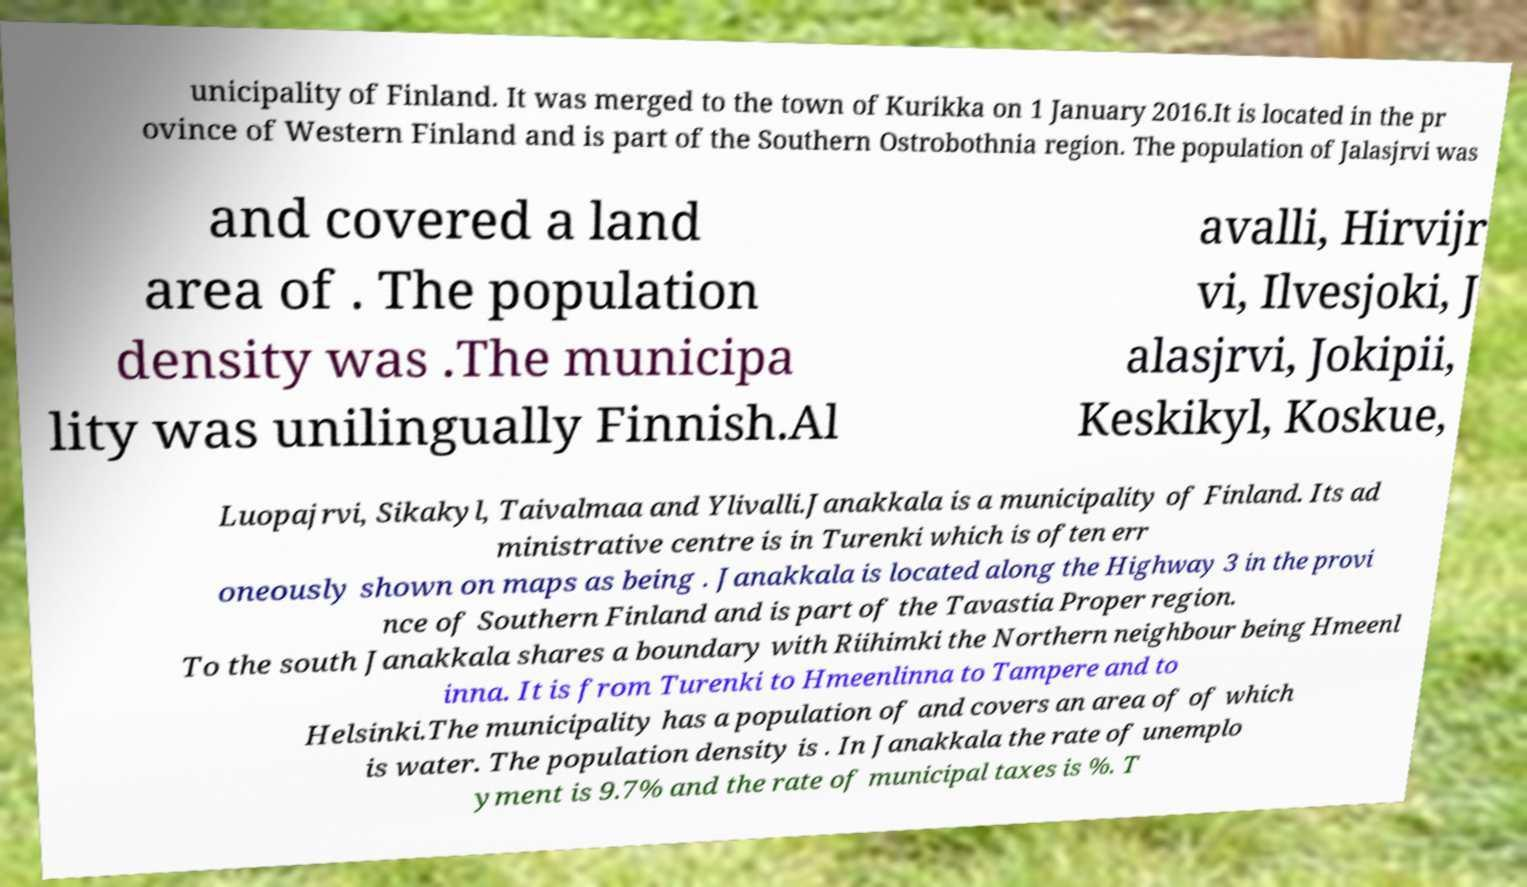For documentation purposes, I need the text within this image transcribed. Could you provide that? unicipality of Finland. It was merged to the town of Kurikka on 1 January 2016.It is located in the pr ovince of Western Finland and is part of the Southern Ostrobothnia region. The population of Jalasjrvi was and covered a land area of . The population density was .The municipa lity was unilingually Finnish.Al avalli, Hirvijr vi, Ilvesjoki, J alasjrvi, Jokipii, Keskikyl, Koskue, Luopajrvi, Sikakyl, Taivalmaa and Ylivalli.Janakkala is a municipality of Finland. Its ad ministrative centre is in Turenki which is often err oneously shown on maps as being . Janakkala is located along the Highway 3 in the provi nce of Southern Finland and is part of the Tavastia Proper region. To the south Janakkala shares a boundary with Riihimki the Northern neighbour being Hmeenl inna. It is from Turenki to Hmeenlinna to Tampere and to Helsinki.The municipality has a population of and covers an area of of which is water. The population density is . In Janakkala the rate of unemplo yment is 9.7% and the rate of municipal taxes is %. T 